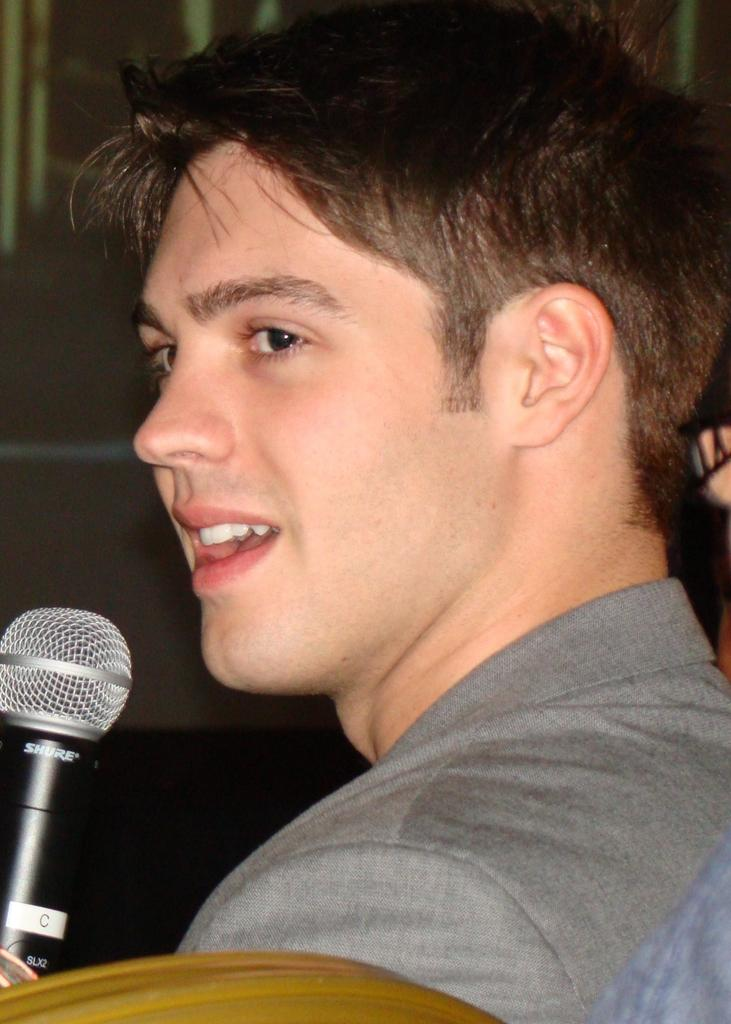What is the main subject of the image? There is a person in the image. What is the person wearing? The person is wearing a blazer. What object is the person holding? The person is holding a microphone (mike). What can be seen in the background of the image? There is a wall in the background of the image. What piece of furniture is at the bottom of the image? There is a chair at the bottom of the image. How many bags can be seen on the person's head in the image? There are no bags visible on the person's head in the image. What type of duck is sitting on the chair in the image? There are no ducks present in the image; it only features a person, a microphone, a wall, and a chair. 